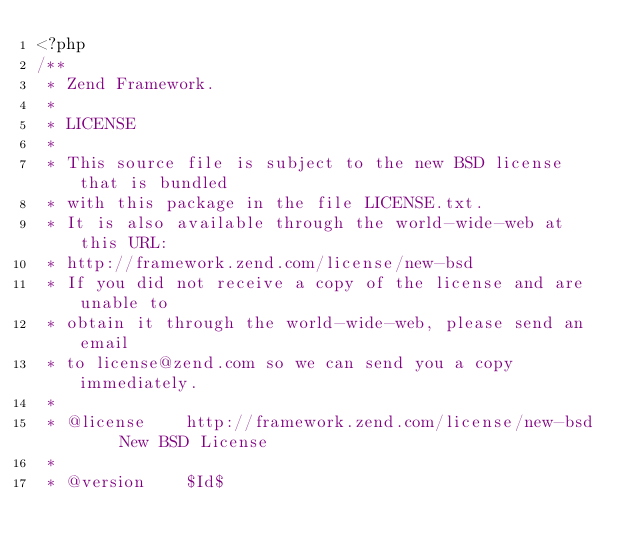<code> <loc_0><loc_0><loc_500><loc_500><_PHP_><?php
/**
 * Zend Framework.
 *
 * LICENSE
 *
 * This source file is subject to the new BSD license that is bundled
 * with this package in the file LICENSE.txt.
 * It is also available through the world-wide-web at this URL:
 * http://framework.zend.com/license/new-bsd
 * If you did not receive a copy of the license and are unable to
 * obtain it through the world-wide-web, please send an email
 * to license@zend.com so we can send you a copy immediately.
 *
 * @license    http://framework.zend.com/license/new-bsd     New BSD License
 *
 * @version    $Id$</code> 